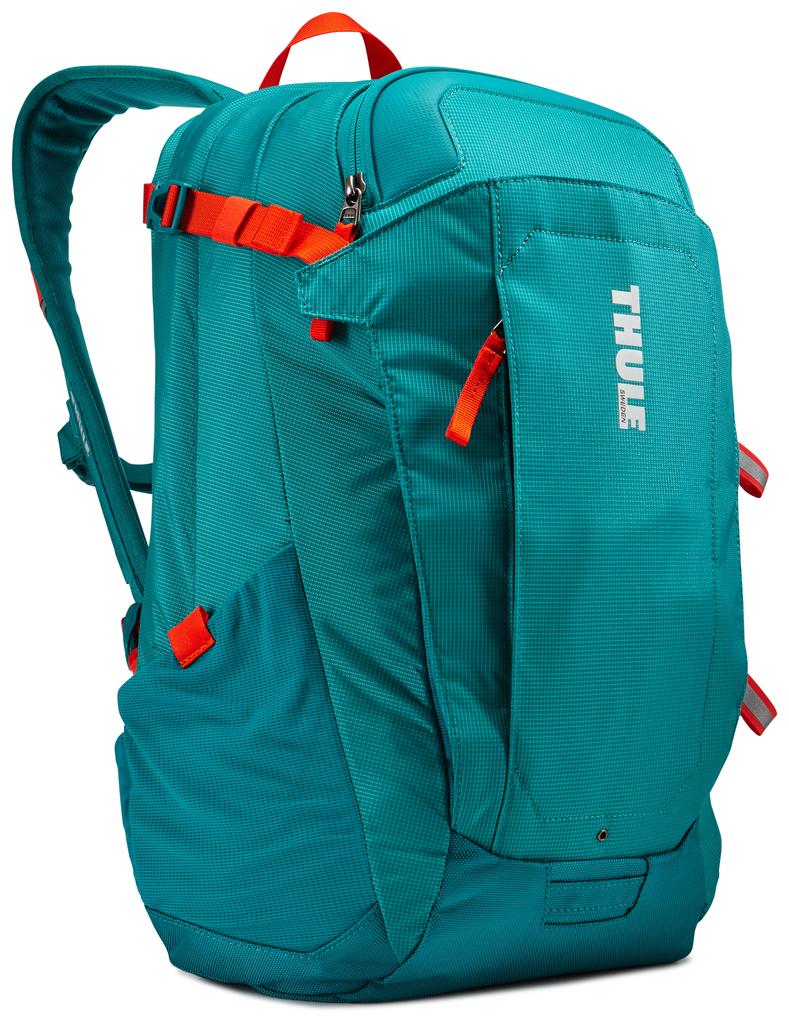What is the brand of backpack?
Offer a very short reply. Thule. 